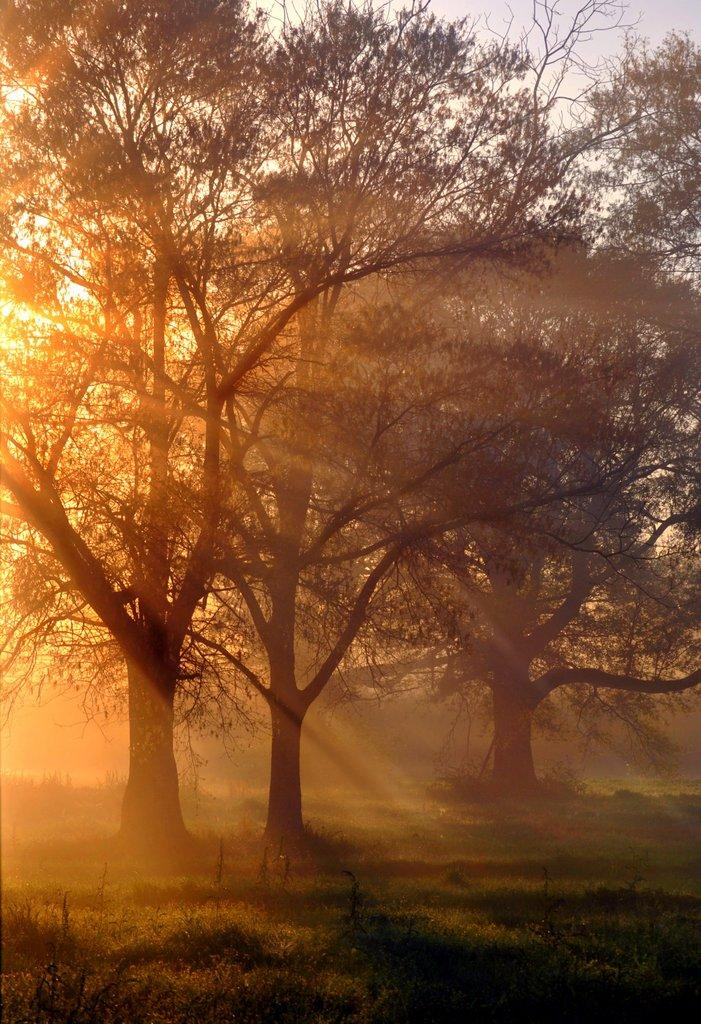What type of vegetation is present in the image? There is grass in the image. What other natural elements can be seen in the image? There are many trees in the image. What is visible in the background of the image? The sky is visible in the background of the image. Can you see any sticks or verses written on the grass in the image? There are no sticks or verses visible on the grass in the image. Is there a rifle present in the image? There is no rifle present in the image. 